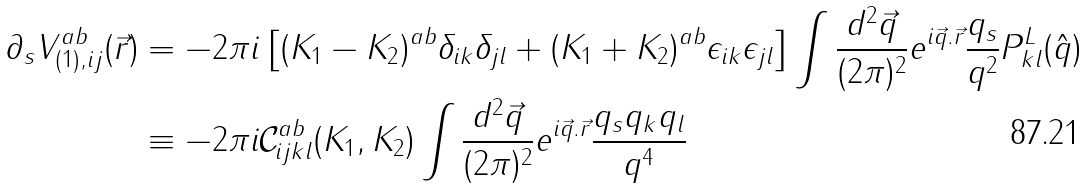<formula> <loc_0><loc_0><loc_500><loc_500>\partial _ { s } V _ { ( 1 ) , i j } ^ { a b } ( \vec { r } ) & = - 2 \pi i \left [ ( K _ { 1 } - K _ { 2 } ) ^ { a b } \delta _ { i k } \delta _ { j l } + ( K _ { 1 } + K _ { 2 } ) ^ { a b } \epsilon _ { i k } \epsilon _ { j l } \right ] \int \frac { d ^ { 2 } \vec { q } } { ( 2 \pi ) ^ { 2 } } e ^ { i \vec { q } . \vec { r } } \frac { q _ { s } } { q ^ { 2 } } P _ { k l } ^ { L } ( \hat { q } ) \\ & \equiv - 2 \pi i \mathcal { C } _ { i j k l } ^ { a b } ( K _ { 1 } , K _ { 2 } ) \int \frac { d ^ { 2 } \vec { q } } { ( 2 \pi ) ^ { 2 } } e ^ { i \vec { q } . \vec { r } } \frac { q _ { s } q _ { k } q _ { l } } { q ^ { 4 } }</formula> 